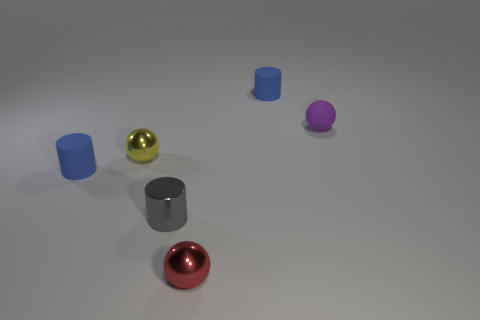Do the tiny yellow metallic thing and the small red object have the same shape?
Provide a succinct answer. Yes. There is a metal cylinder that is the same size as the purple ball; what is its color?
Provide a succinct answer. Gray. Is the number of red balls that are behind the tiny yellow thing the same as the number of tiny gray metal things?
Provide a succinct answer. No. The thing that is in front of the rubber sphere and to the right of the tiny shiny cylinder has what shape?
Keep it short and to the point. Sphere. Is the size of the gray metallic cylinder the same as the yellow shiny ball?
Offer a terse response. Yes. Is there a red ball made of the same material as the small yellow thing?
Provide a succinct answer. Yes. How many small blue cylinders are behind the small purple object and left of the tiny gray metal cylinder?
Keep it short and to the point. 0. There is a tiny blue cylinder that is behind the small matte sphere; what material is it?
Offer a very short reply. Rubber. What number of small metallic spheres are the same color as the small rubber ball?
Your answer should be compact. 0. There is a gray thing that is made of the same material as the small yellow thing; what is its size?
Make the answer very short. Small. 